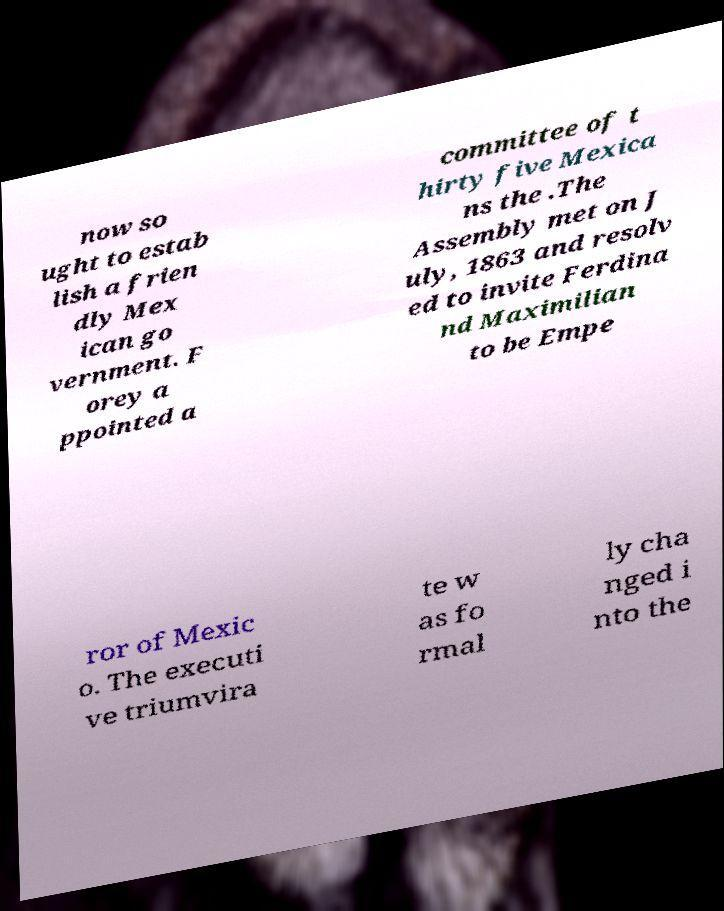Please read and relay the text visible in this image. What does it say? now so ught to estab lish a frien dly Mex ican go vernment. F orey a ppointed a committee of t hirty five Mexica ns the .The Assembly met on J uly, 1863 and resolv ed to invite Ferdina nd Maximilian to be Empe ror of Mexic o. The executi ve triumvira te w as fo rmal ly cha nged i nto the 